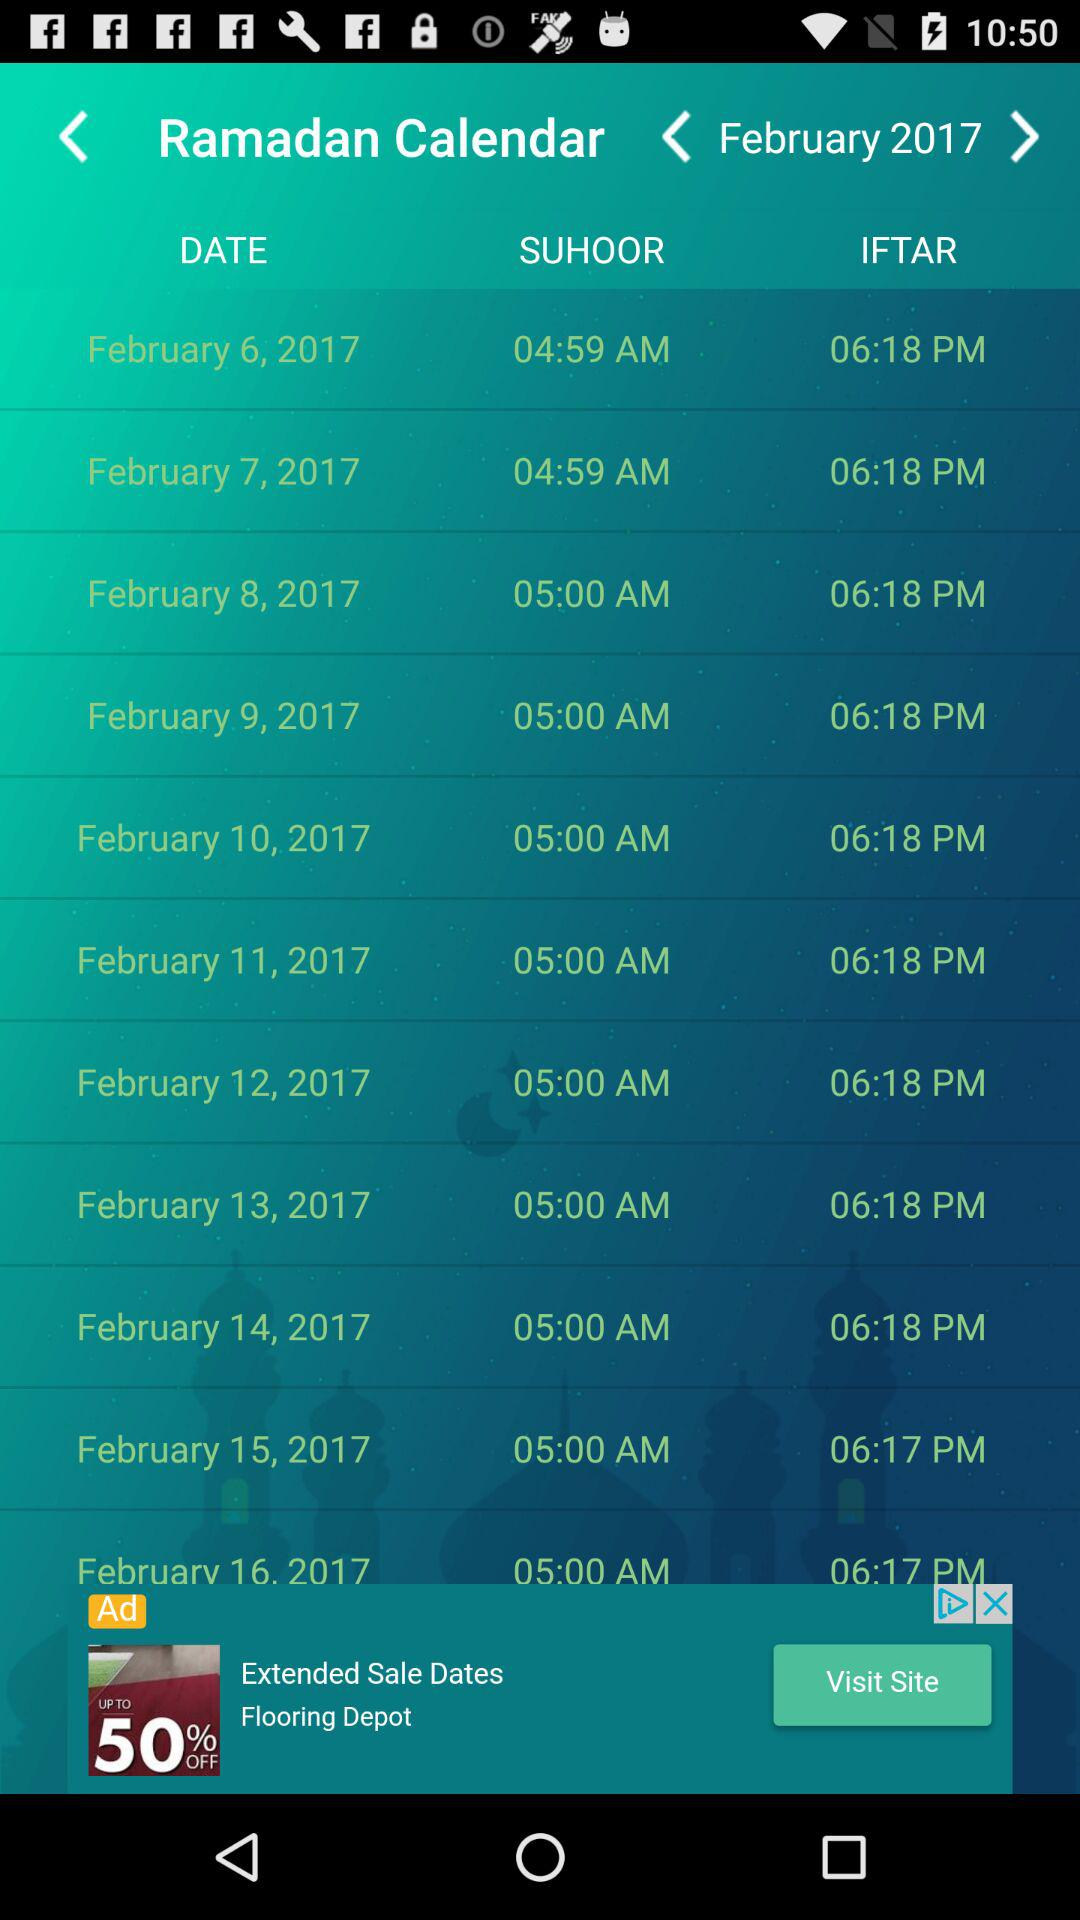What is the suhoor time on 9th of February? The suhoor time is 5:00 AM. 